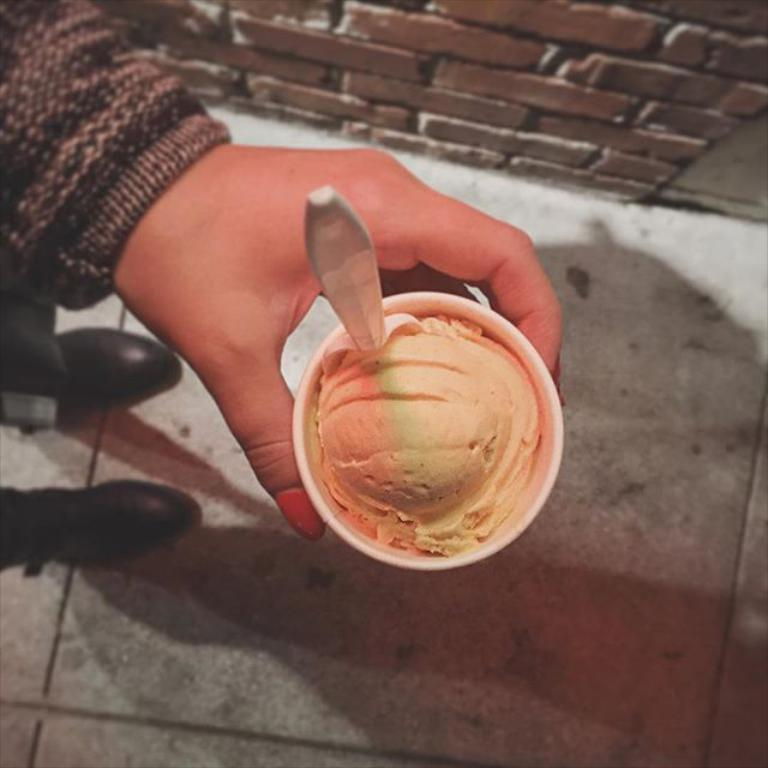What is the person holding in the image? The person is holding an ice-cream in the image. How is the ice-cream contained? The ice-cream is in a cup. What can be seen in the background of the image? The wall in the background is brown. What type of business is being conducted in the image? There is no indication of any business being conducted in the image; it primarily features a person holding an ice-cream. 